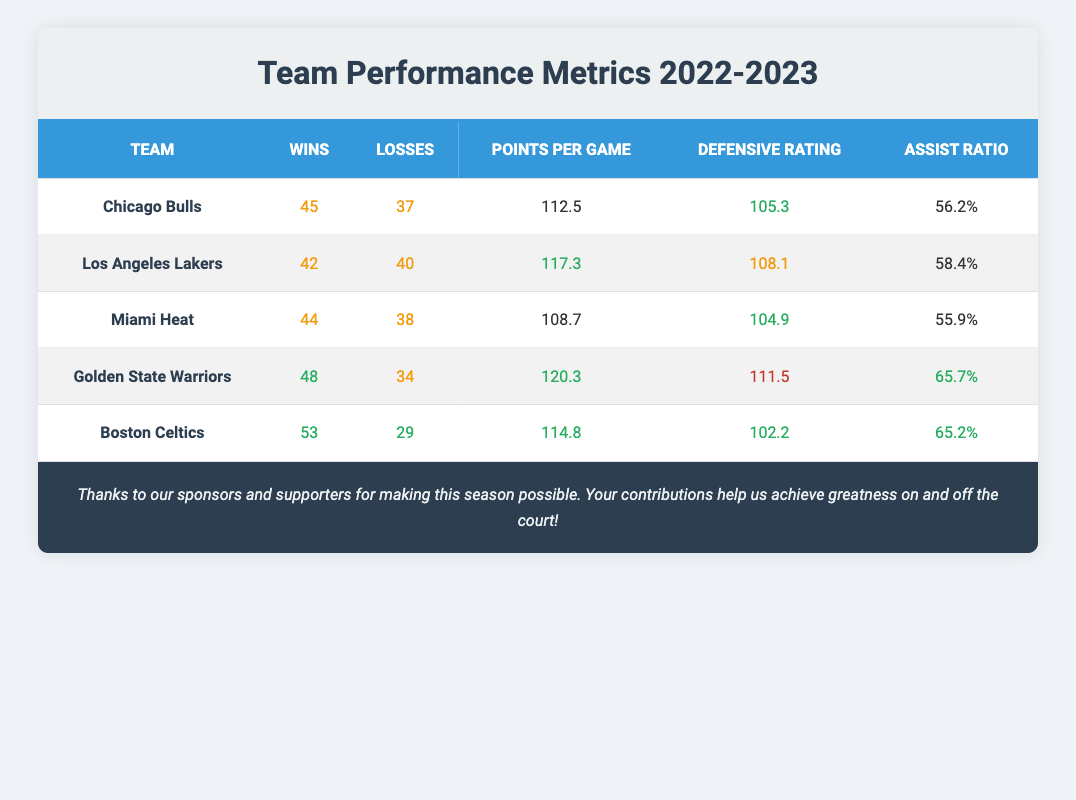What is the highest number of wins in the table? The wins column shows values for each team: 45 (Chicago Bulls), 42 (Los Angeles Lakers), 44 (Miami Heat), 48 (Golden State Warriors), and 53 (Boston Celtics). Among these values, the highest is 53 for the Boston Celtics.
Answer: 53 Which team had the lowest defensive rating? The defensive ratings for the teams are: 105.3 (Chicago Bulls), 108.1 (Los Angeles Lakers), 104.9 (Miami Heat), 111.5 (Golden State Warriors), and 102.2 (Boston Celtics). The lowest value is 102.2 for the Boston Celtics.
Answer: Boston Celtics What is the average points per game for all teams? The points per game are: 112.5 (Bulls), 117.3 (Lakers), 108.7 (Heat), 120.3 (Warriors), and 114.8 (Celtics). To find the average, sum these values (112.5 + 117.3 + 108.7 + 120.3 + 114.8 = 573.6) and divide by the number of teams (5). The average points per game is 573.6 / 5 = 114.72.
Answer: 114.72 Did any team have more than 50 wins? Checking the wins column, the teams with wins are: 45, 42, 44, 48, and 53. Only the Boston Celtics with 53 wins exceeded the 50-win mark.
Answer: Yes Which team had the best assist ratio and what was it? The assist ratios are: 56.2% (Bulls), 58.4% (Lakers), 55.9% (Heat), 65.7% (Warriors), and 65.2% (Celtics). The highest assist ratio is 65.7% for the Golden State Warriors.
Answer: 65.7% for Golden State Warriors How many losses do the Miami Heat have? The losses column shows values for each team, specifically for the Miami Heat it displays 38 losses directly in the table.
Answer: 38 What is the difference in wins between the Chicago Bulls and the Golden State Warriors? The Chicago Bulls have 45 wins, and the Golden State Warriors have 48 wins. To find the difference, subtract the Bulls' wins from the Warriors' wins: 48 - 45 = 3.
Answer: 3 Which teams had a defensive rating below 110? The defensive ratings are 105.3 (Bulls), 108.1 (Lakers), 104.9 (Heat), 111.5 (Warriors), and 102.2 (Celtics). The teams with ratings below 110 are the Bulls, Heat, and Celtics.
Answer: Bulls, Heat, Celtics What percentage of games did the Golden State Warriors win? The Golden State Warriors won 48 out of 82 games (48 wins plus 34 losses). To calculate the win percentage: (48 / (48 + 34)) * 100 = (48 / 82) * 100 = 58.54%.
Answer: 58.54% 